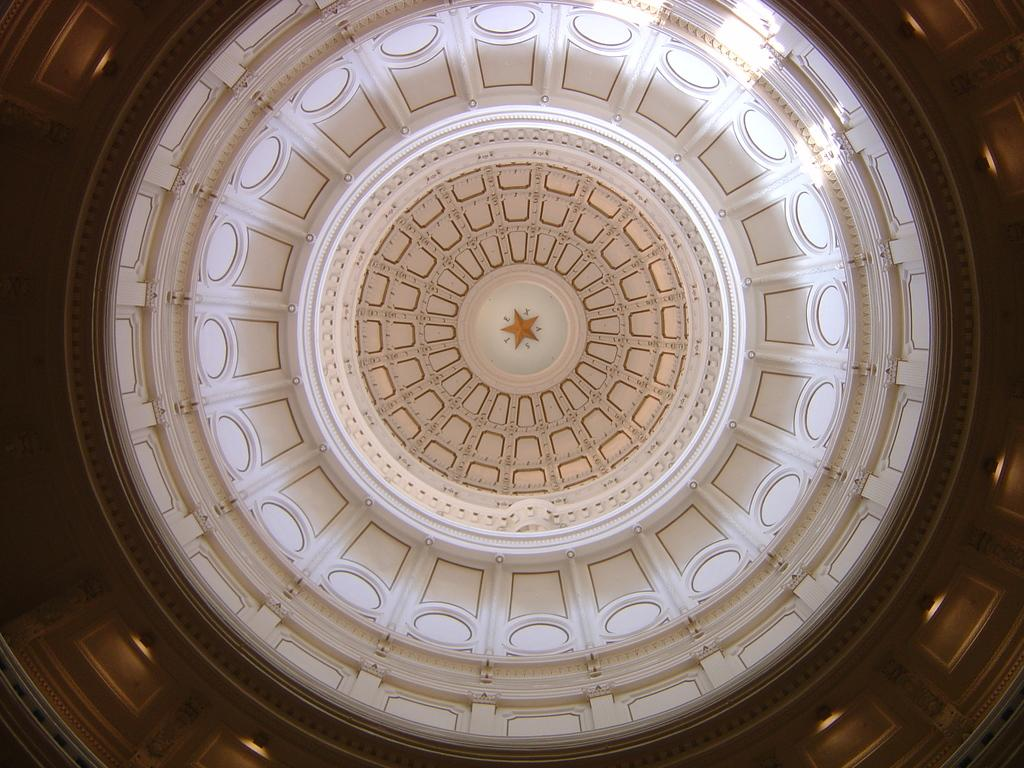What is hanging from the ceiling in the image? There are lights on the ceiling in the image. What can be seen on the roof in the image? There is a designed roof in the image. How many thumbs can be seen on the roof in the image? There are no thumbs present on the roof in the image. What type of feathers can be seen on the lights in the image? There are no feathers present on the lights in the image. 